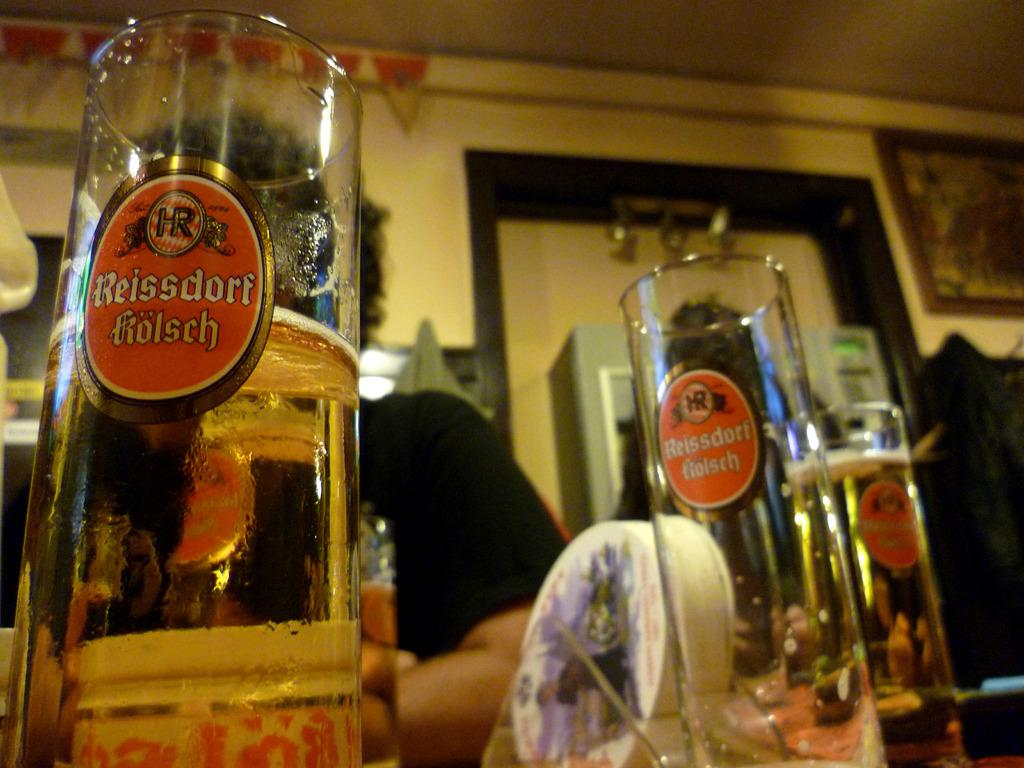<image>
Summarize the visual content of the image. a glass that is half full and labeled reissdort tiolsch 